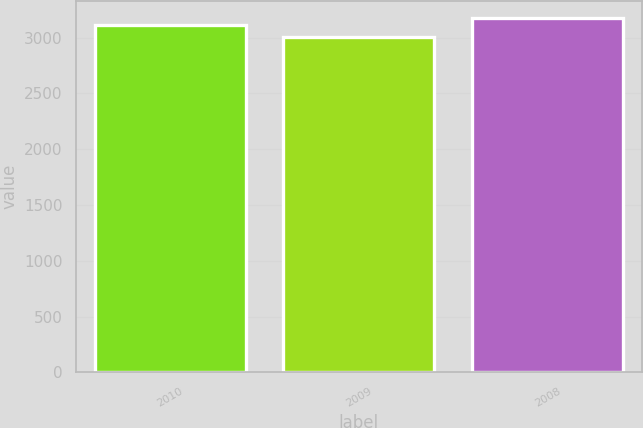Convert chart. <chart><loc_0><loc_0><loc_500><loc_500><bar_chart><fcel>2010<fcel>2009<fcel>2008<nl><fcel>3110<fcel>3007<fcel>3174<nl></chart> 